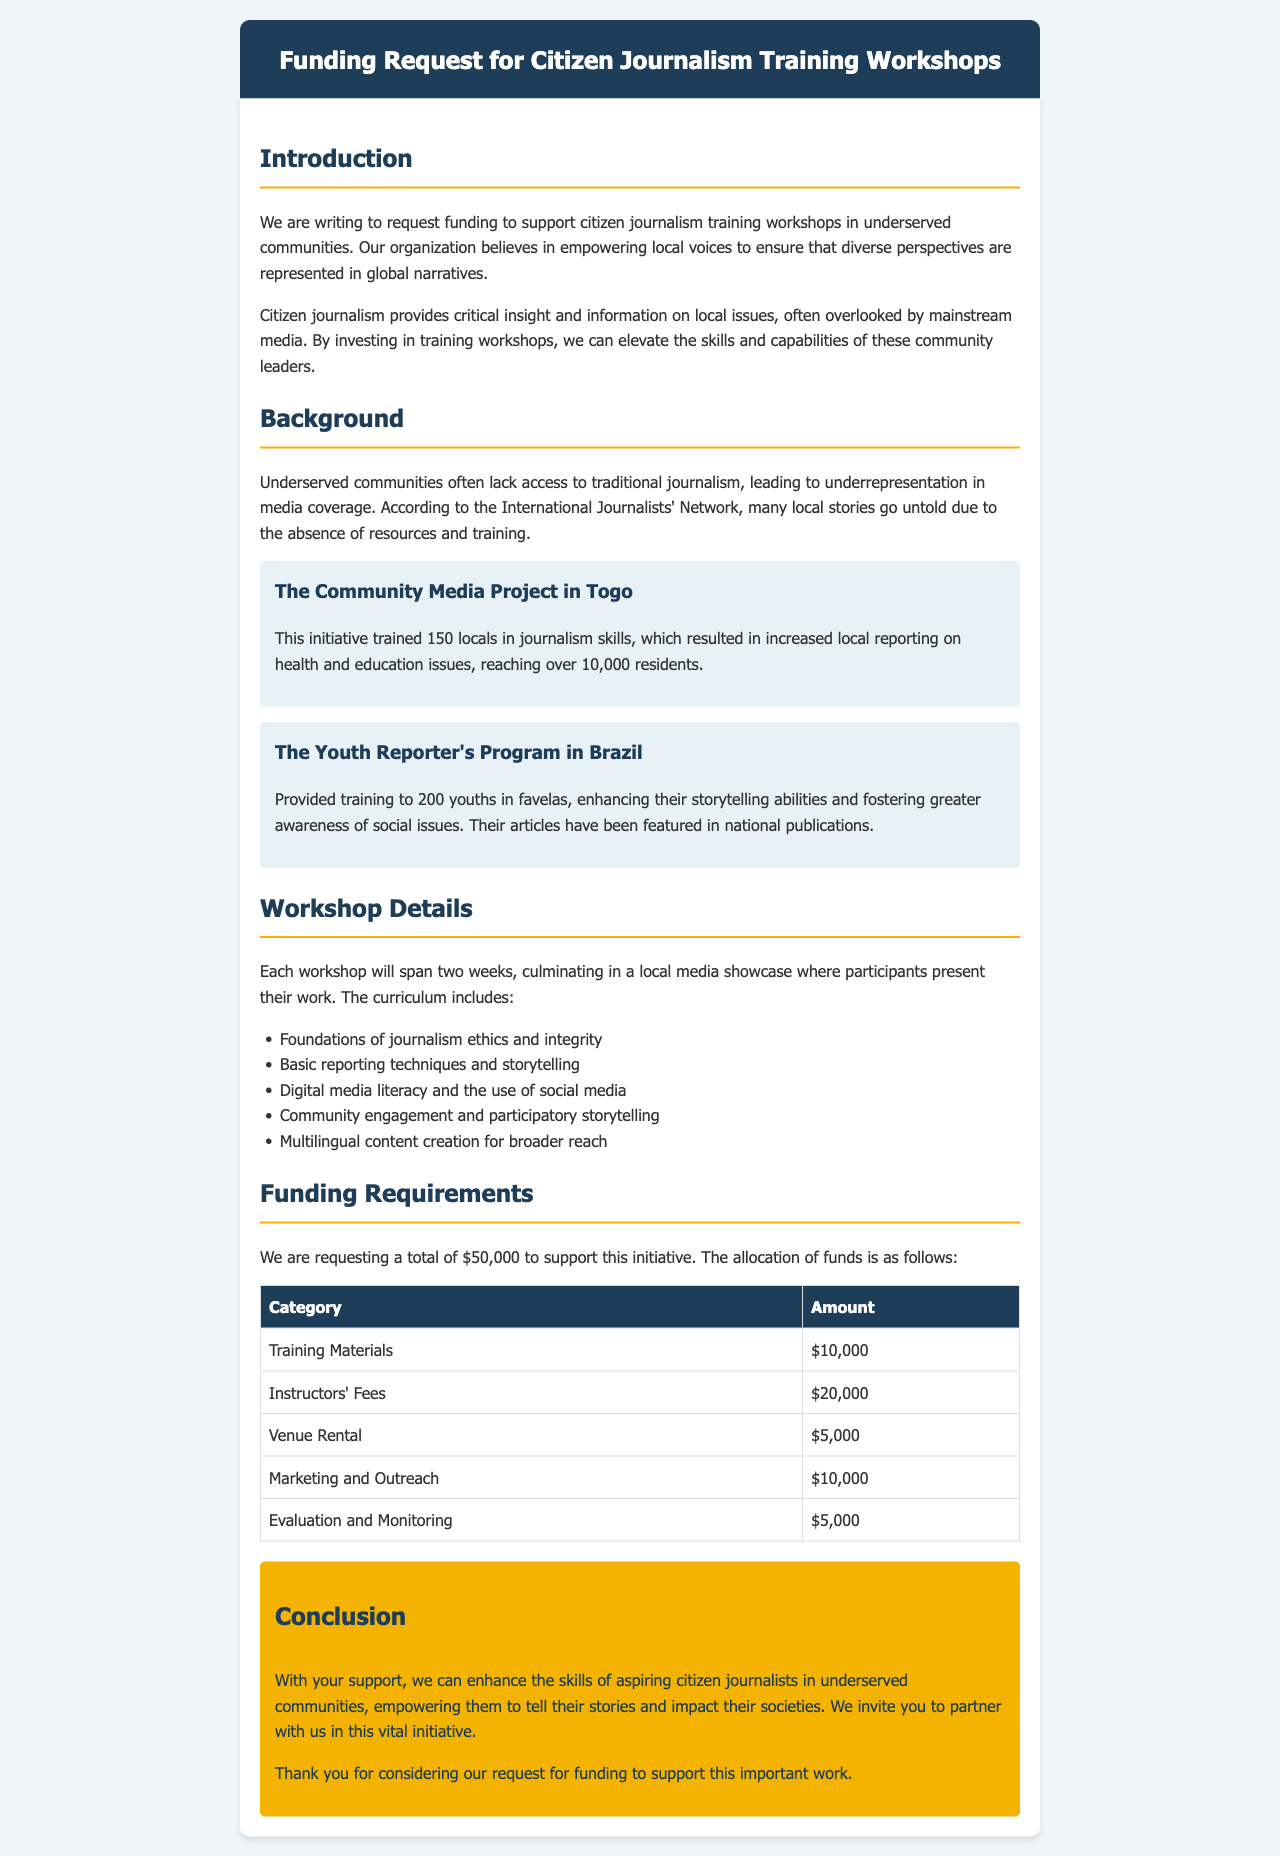What is the total funding requested? The total funding requested is clearly stated in the document as $50,000.
Answer: $50,000 What is one of the workshop curriculum topics? The document lists several topics in the curriculum, one of which is "Basic reporting techniques and storytelling."
Answer: Basic reporting techniques and storytelling How many locals were trained in Togo? The letter specifically mentions that 150 locals were trained in journalism skills in Togo.
Answer: 150 What is the amount allocated for instructors' fees? The funding allocation table indicates that instructors' fees amount to $20,000.
Answer: $20,000 What is the goal of the funding request? The document states that the goal is to support citizen journalism training workshops in underserved communities.
Answer: Support citizen journalism training workshops Who does the organization aim to empower? The letter emphasizes that the organization aims to empower local voices in underserved communities.
Answer: Local voices What is the duration of each workshop? The document states that each workshop will span two weeks.
Answer: Two weeks What initiative trained youths in Brazil? The letter references "The Youth Reporter's Program in Brazil" as the initiative that trained youths.
Answer: The Youth Reporter's Program in Brazil What is the purpose of the local media showcase? The document explains that the local media showcase is where participants present their work after the workshop.
Answer: Participants present their work 